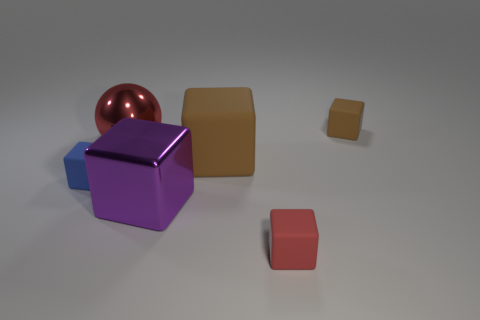There is another thing that is the same color as the large matte object; what is its material?
Make the answer very short. Rubber. Is the size of the red sphere the same as the brown object that is left of the red matte block?
Provide a succinct answer. Yes. How many other things are there of the same material as the tiny blue object?
Your answer should be compact. 3. There is a large thing that is both behind the small blue object and on the left side of the big brown thing; what is its shape?
Offer a terse response. Sphere. There is a rubber thing on the right side of the red rubber block; does it have the same size as the object to the left of the red shiny ball?
Offer a terse response. Yes. The other large thing that is made of the same material as the purple object is what shape?
Your answer should be compact. Sphere. Are there any other things that have the same shape as the small blue thing?
Your response must be concise. Yes. What color is the matte cube that is in front of the rubber block on the left side of the big metal block that is in front of the large red metallic thing?
Offer a very short reply. Red. Is the number of tiny rubber things that are right of the large ball less than the number of big brown matte cubes to the left of the large matte cube?
Give a very brief answer. No. Is the shape of the small brown rubber object the same as the big brown rubber object?
Your answer should be compact. Yes. 